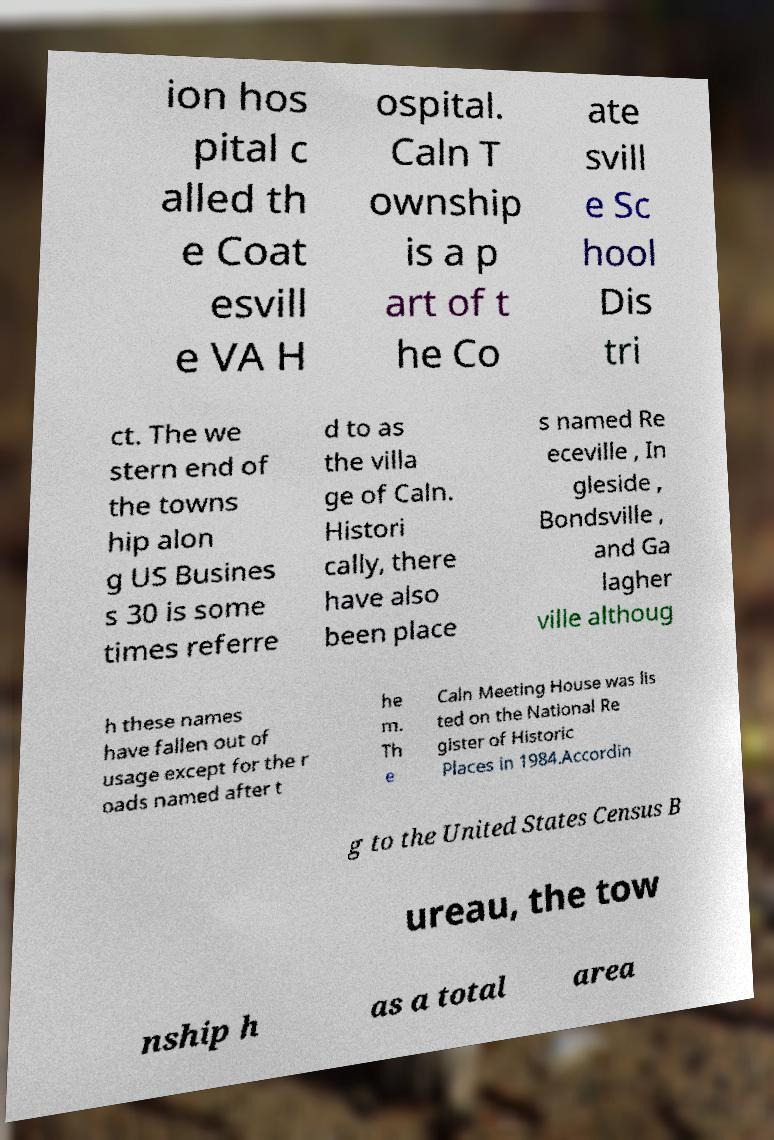Could you assist in decoding the text presented in this image and type it out clearly? ion hos pital c alled th e Coat esvill e VA H ospital. Caln T ownship is a p art of t he Co ate svill e Sc hool Dis tri ct. The we stern end of the towns hip alon g US Busines s 30 is some times referre d to as the villa ge of Caln. Histori cally, there have also been place s named Re eceville , In gleside , Bondsville , and Ga lagher ville althoug h these names have fallen out of usage except for the r oads named after t he m. Th e Caln Meeting House was lis ted on the National Re gister of Historic Places in 1984.Accordin g to the United States Census B ureau, the tow nship h as a total area 